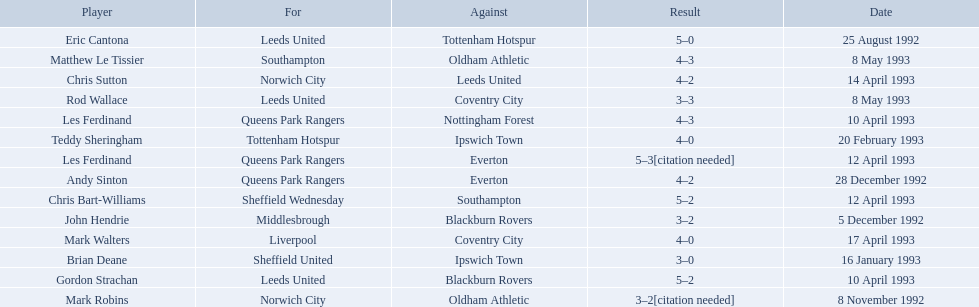What are the results? 5–0, 3–2[citation needed], 3–2, 4–2, 3–0, 4–0, 5–2, 4–3, 5–2, 5–3[citation needed], 4–2, 4–0, 3–3, 4–3. What result did mark robins have? 3–2[citation needed]. What other player had that result? John Hendrie. 